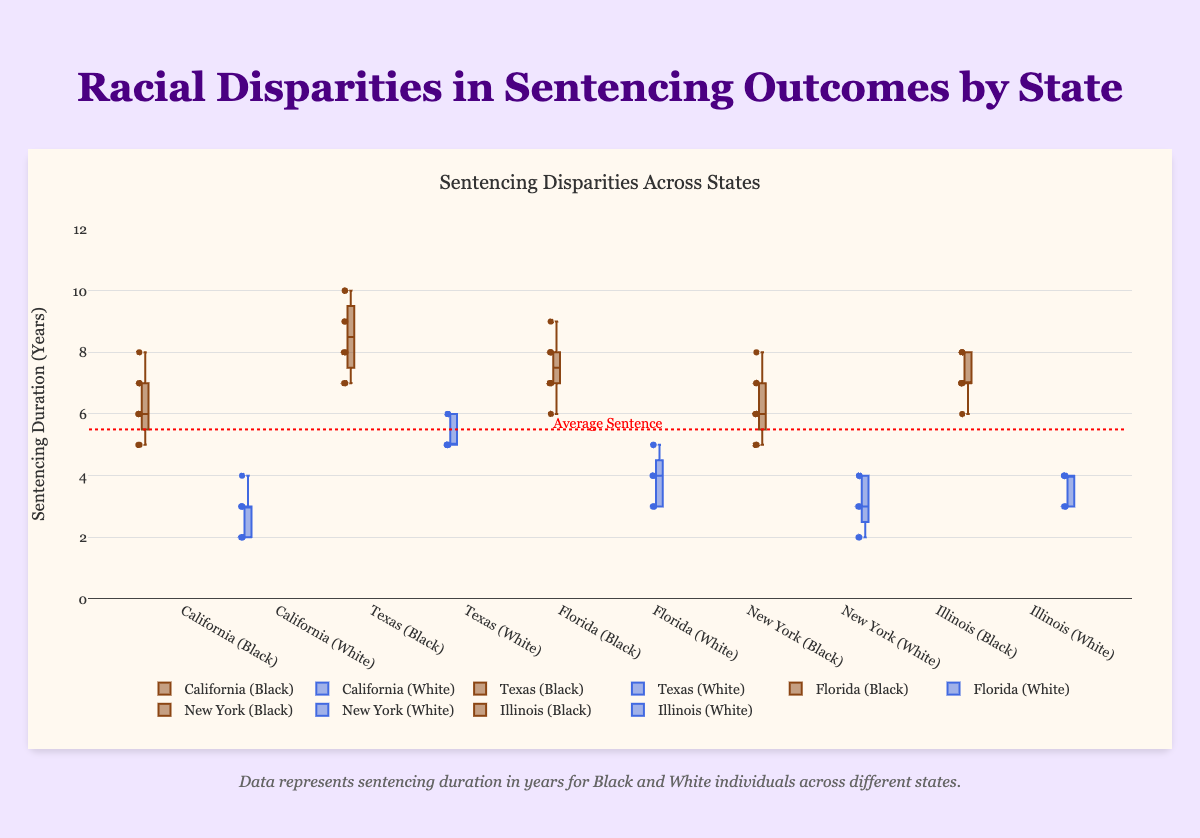Which state has the median sentencing duration of Black individuals at 8 years? By inspecting the box plots, we identify that the median line within the box representing Black individuals at 8 years is only visible in the Texas and Illinois plots.
Answer: Texas and Illinois What is the title of the box plot? The title is prominently placed at the top of the chart. It reads "Sentencing Disparities Across States".
Answer: Sentencing Disparities Across States In which state do Black individuals have the highest observed sentencing duration? The maximum point for Black individuals can be observed in the Texas plot, where sentencing duration reaches 10 years.
Answer: Texas Which racial group in California has a lower median sentencing duration? By comparing the median lines within the California box plots, the median for White individuals is visibly lower than for Black individuals.
Answer: White individuals How does the range of sentencing durations for White individuals in Texas compare to those in Florida? The range can be identified by observing the distance between the minimum and maximum points in the box plots. For White individuals, Texas ranges from 5 to 6 years, and Florida ranges from 3 to 5 years.
Answer: Texas has a narrower range than Florida What is the average sentence indicated on the chart and how is it represented? The chart includes an average sentence line drawn at 5.5 years represented by a red dashed line. It also uses a textual annotation to signify this average.
Answer: 5.5 years Which racial group in New York has a wider interquartile range (IQR) in sentencing duration? The width of the IQR, represented by the width of the colored box (from the lower quartile to the upper quartile), is wider for Black individuals than for White individuals in New York.
Answer: Black individuals What is the typical median sentencing duration for White individuals across the observed states? By inspecting each box plot, the median line for White individuals: California (3), Texas (5.5), Florida (4), New York (3), and Illinois (3.5). The most frequent value among these is 3 years.
Answer: 3 years Which state shows the least disparity between the sentencing durations of Black and White individuals? By comparing the box plots for each state, the one with the closest medians for Black and White individuals indicates the least disparity. California shows a significant disparity, whereas Illinois has closer medians for both groups.
Answer: Illinois In Florida, do White individuals ever receive a sentencing duration that exceeds the minimum received by Black individuals? By inspecting the plot for Florida, we see that the maximum point for White individuals (5 years) is greater than the minimum point for Black individuals (6 years).
Answer: No 